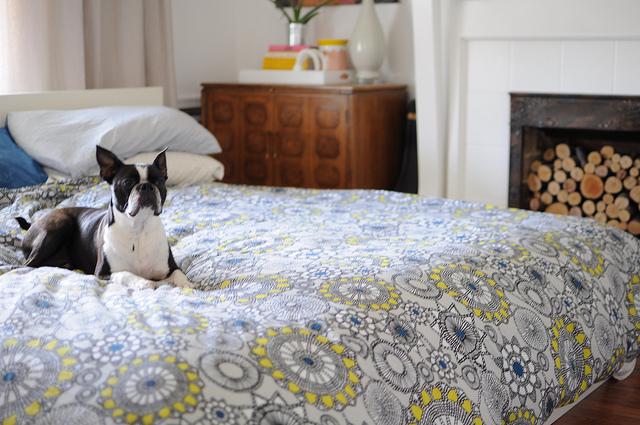What else is on the bed?
Answer briefly. Dog. What animal is on the bed?
Short answer required. Dog. What is inside the fireplace?
Be succinct. Wood. 